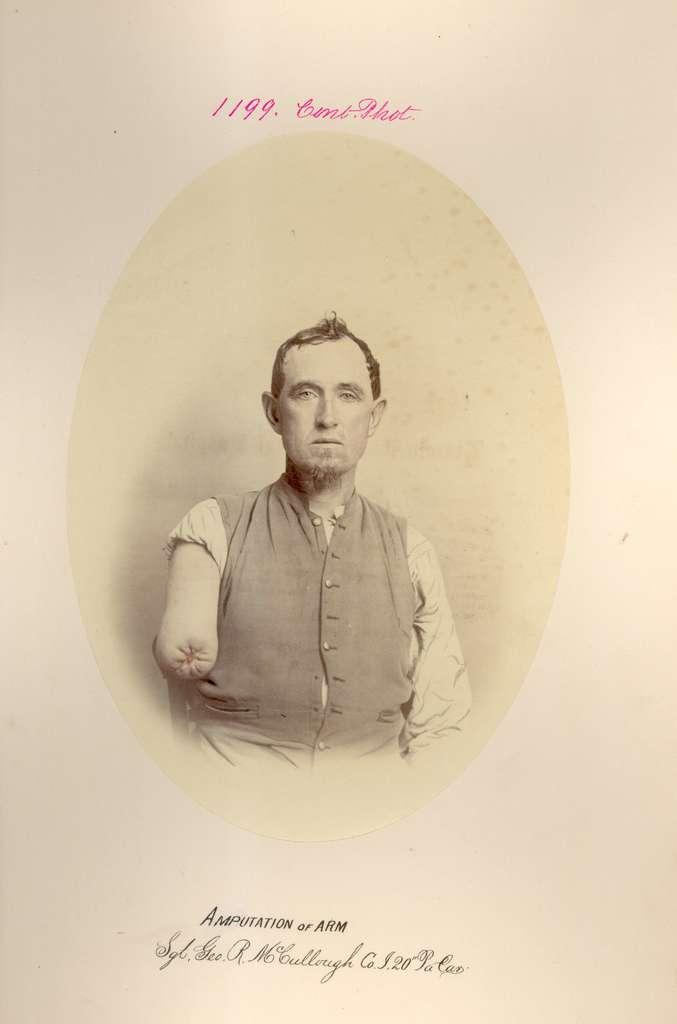What is there is a photo of a person in the image, can you describe the person? The provided facts do not include a description of the person in the photo. What is written on the photo? The facts mention that there is text written on the photo, but the content of the text is not specified. What type of drum can be seen in the image? There is no drum present in the image; it only contains a photo with text written on it. Can you describe the beast that is interacting with the text in the image? There is no beast present in the image; it only contains a photo with text written on it. 